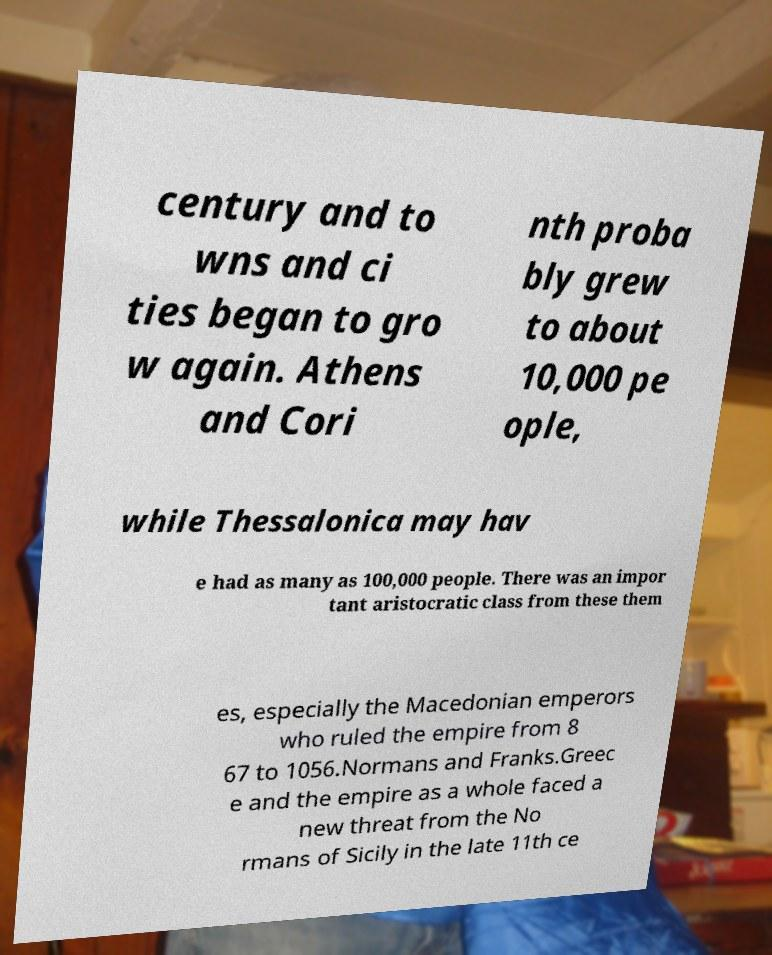Could you assist in decoding the text presented in this image and type it out clearly? century and to wns and ci ties began to gro w again. Athens and Cori nth proba bly grew to about 10,000 pe ople, while Thessalonica may hav e had as many as 100,000 people. There was an impor tant aristocratic class from these them es, especially the Macedonian emperors who ruled the empire from 8 67 to 1056.Normans and Franks.Greec e and the empire as a whole faced a new threat from the No rmans of Sicily in the late 11th ce 